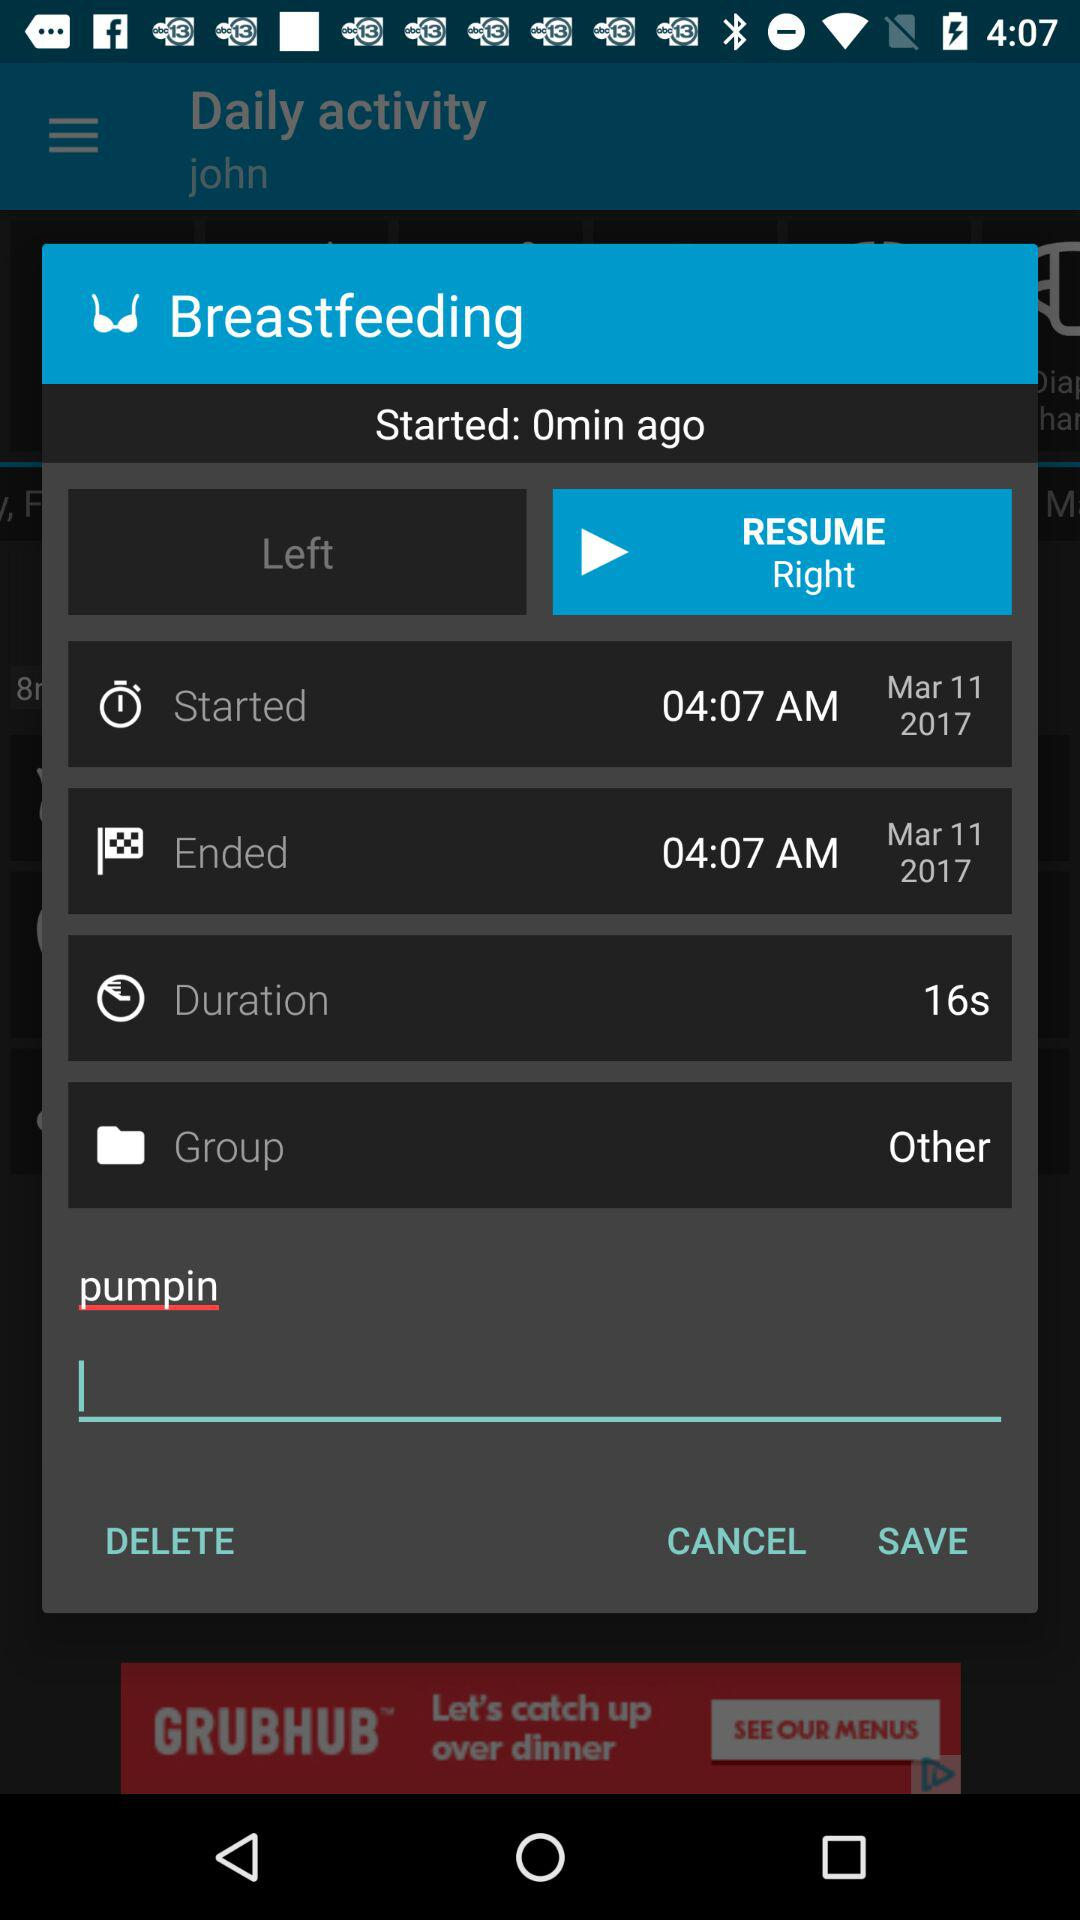What option is selected for "Group"? The selected option for "Group" is "Other". 